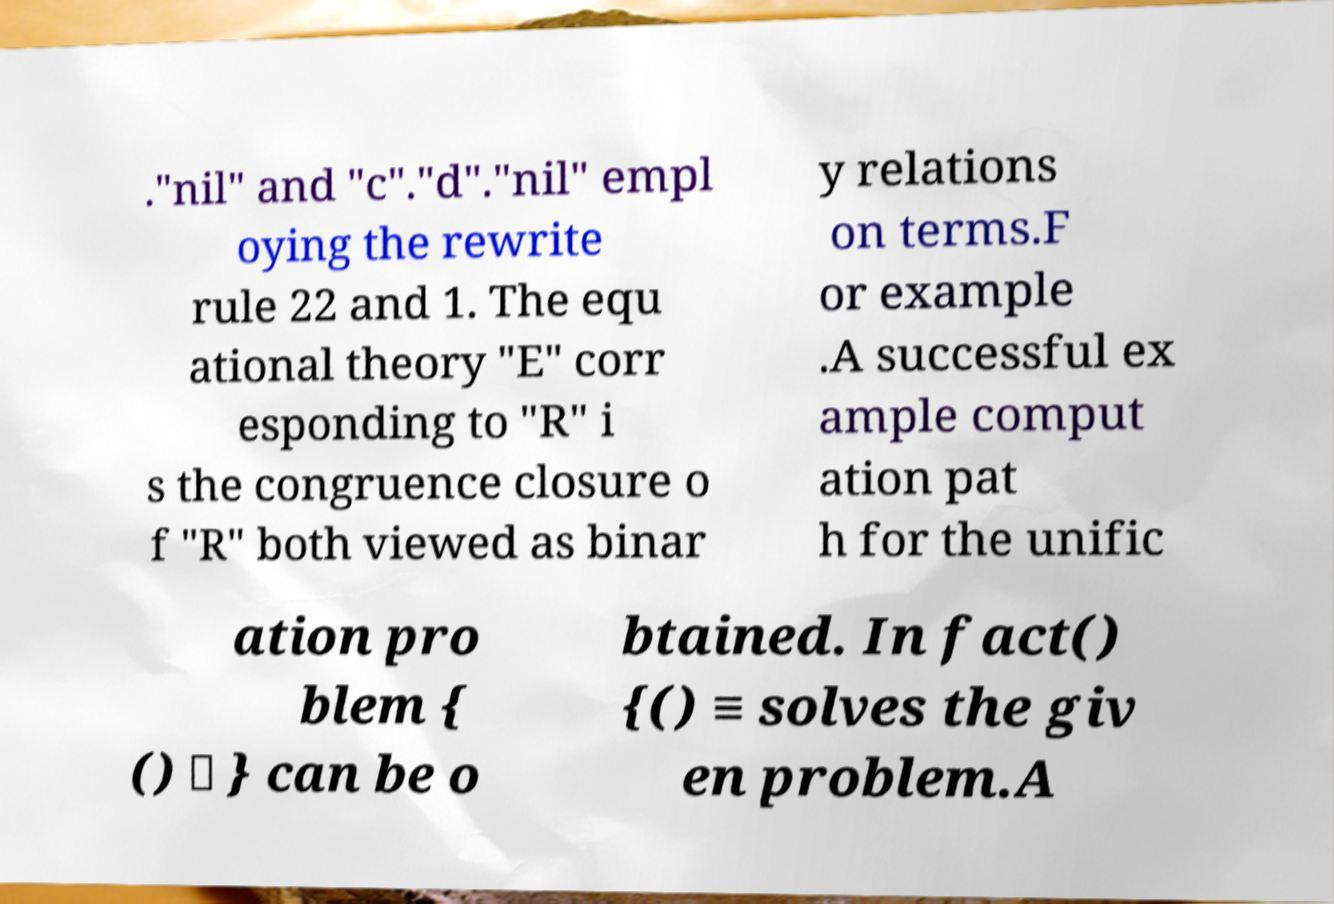There's text embedded in this image that I need extracted. Can you transcribe it verbatim? ."nil" and "c"."d"."nil" empl oying the rewrite rule 22 and 1. The equ ational theory "E" corr esponding to "R" i s the congruence closure o f "R" both viewed as binar y relations on terms.F or example .A successful ex ample comput ation pat h for the unific ation pro blem { () ≐ } can be o btained. In fact() {() ≡ solves the giv en problem.A 